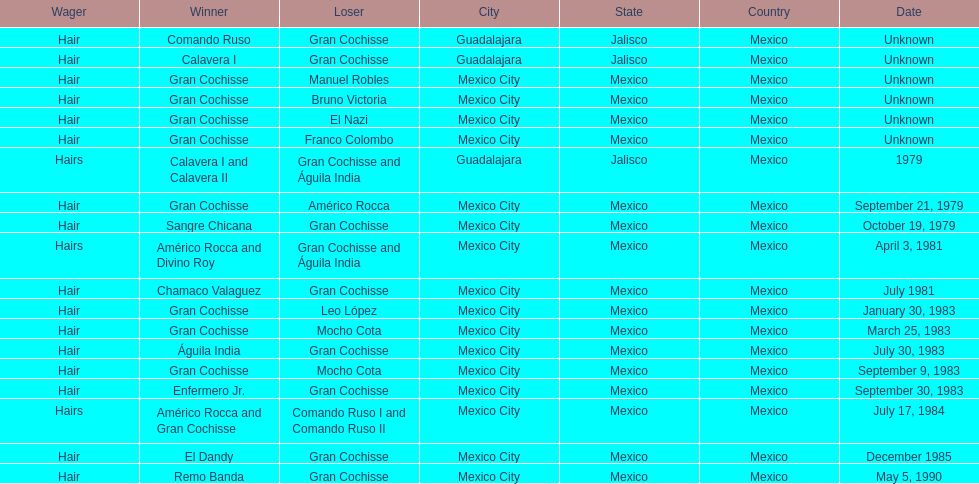What was the number of losses gran cochisse had against el dandy? 1. 